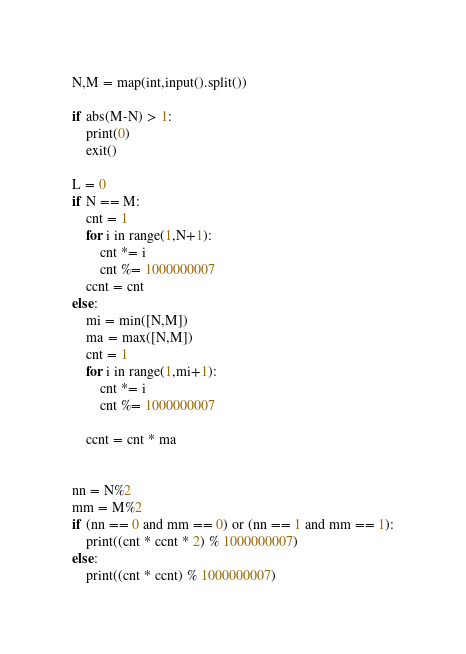<code> <loc_0><loc_0><loc_500><loc_500><_Python_>N,M = map(int,input().split())

if abs(M-N) > 1:
    print(0)
    exit()

L = 0
if N == M:
    cnt = 1
    for i in range(1,N+1):
        cnt *= i
        cnt %= 1000000007
    ccnt = cnt
else:
    mi = min([N,M])
    ma = max([N,M])
    cnt = 1
    for i in range(1,mi+1):
        cnt *= i
        cnt %= 1000000007

    ccnt = cnt * ma


nn = N%2
mm = M%2
if (nn == 0 and mm == 0) or (nn == 1 and mm == 1):
    print((cnt * ccnt * 2) % 1000000007)
else:
    print((cnt * ccnt) % 1000000007)</code> 